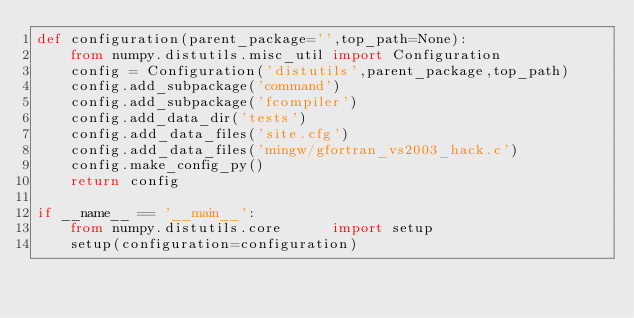<code> <loc_0><loc_0><loc_500><loc_500><_Python_>def configuration(parent_package='',top_path=None):
    from numpy.distutils.misc_util import Configuration
    config = Configuration('distutils',parent_package,top_path)
    config.add_subpackage('command')
    config.add_subpackage('fcompiler')
    config.add_data_dir('tests')
    config.add_data_files('site.cfg')
    config.add_data_files('mingw/gfortran_vs2003_hack.c')
    config.make_config_py()
    return config

if __name__ == '__main__':
    from numpy.distutils.core      import setup
    setup(configuration=configuration)
</code> 